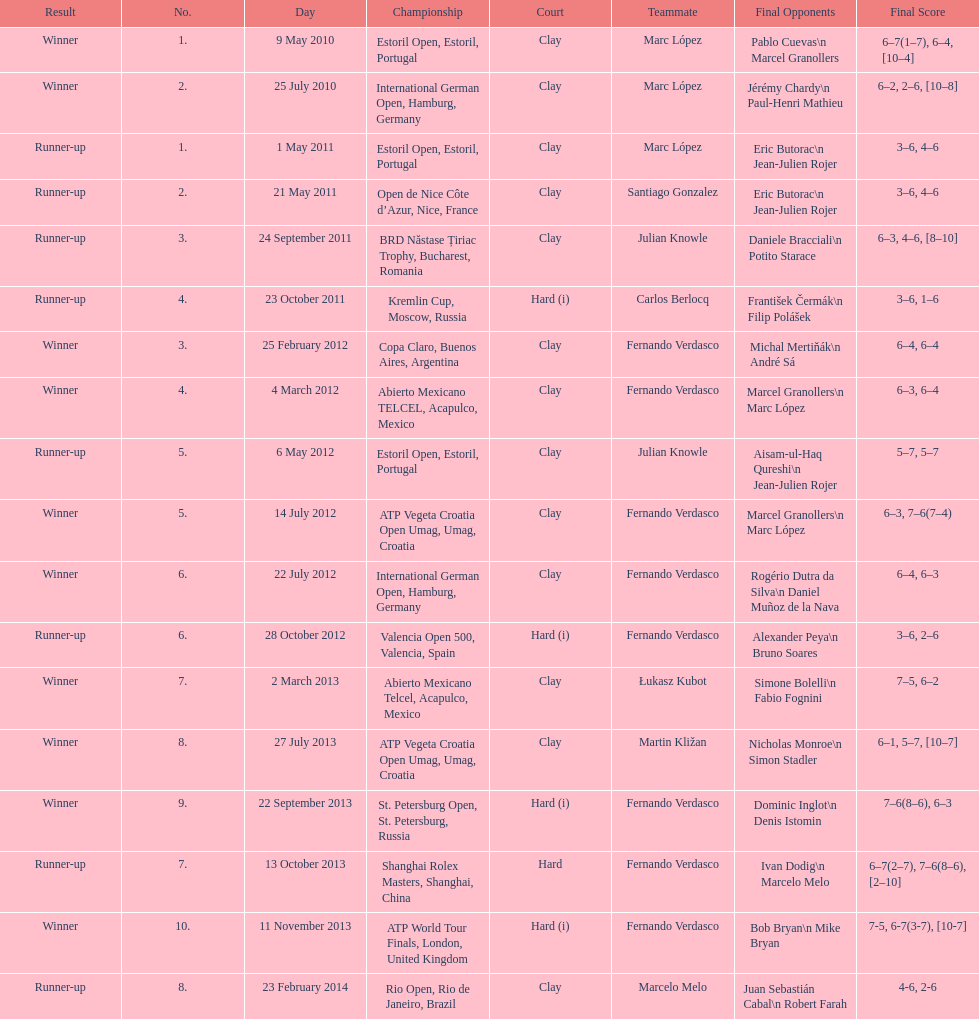How many tournaments has this player won in his career so far? 10. 